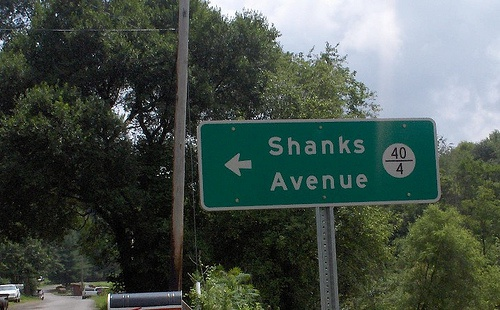Describe the objects in this image and their specific colors. I can see car in black, white, darkgray, and gray tones and car in black, darkgray, and gray tones in this image. 